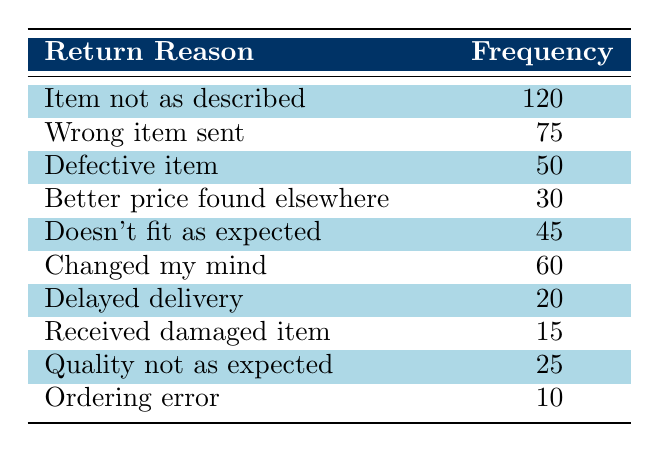What is the most common reason for order returns? The table shows that the highest frequency is 120 for the reason "Item not as described". This indicates that this reason is the most commonly reported for order returns.
Answer: Item not as described How many returns are due to defective items? The table indicates that there are 50 returns due to defective items. This is directly stated in the frequency column next to that reason.
Answer: 50 What percentage of the total returns is due to "Wrong item sent"? First, calculate the total returns by summing all frequencies: 120 + 75 + 50 + 30 + 45 + 60 + 20 + 15 + 25 + 10 = 450. Then, find the frequency of "Wrong item sent", which is 75. The percentage is (75/450) * 100 = 16.67%.
Answer: 16.67% Is the frequency of "Delayed delivery" higher than that of "Quality not as expected"? The frequency of "Delayed delivery" is 20, while "Quality not as expected" has a frequency of 25. Since 20 is less than 25, the statement is false.
Answer: No What is the difference in frequency between "Best price found elsewhere" and "Changed my mind"? The frequency of "Better price found elsewhere" is 30 and for "Changed my mind" it is 60. The difference is 60 - 30 = 30. This means "Changed my mind" has 30 more returns than "Better price found elsewhere".
Answer: 30 What is the total number of returns for the reasons related to poor item quality? The reasons related to poor quality include "Item not as described", "Defective item", "Received damaged item", and "Quality not as expected". Their frequencies are 120, 50, 15, and 25 respectively. Summing these gives 120 + 50 + 15 + 25 = 210. Therefore, the total number of returns due to poor quality is 210.
Answer: 210 Are there more returns attributed to "Ordering error" than "Delayed delivery"? The frequency of "Ordering error" is 10, and for "Delayed delivery" it is 20. Since 10 is less than 20, this statement is false.
Answer: No What is the average frequency of item return reasons listed in the table? There are a total of 10 reasons listed. Sum their frequencies: 120 + 75 + 50 + 30 + 45 + 60 + 20 + 15 + 25 + 10 = 450. To find the average, divide the total by the number of reasons: 450 / 10 = 45.
Answer: 45 